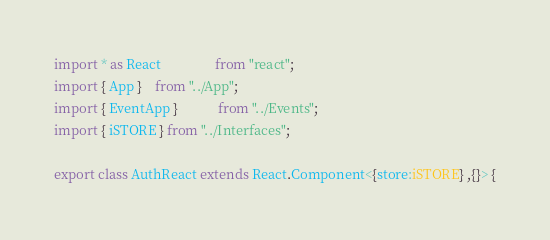<code> <loc_0><loc_0><loc_500><loc_500><_TypeScript_>import * as React 				from "react";
import { App } 	from "../App";
import { EventApp } 			from "../Events";
import { iSTORE } from "../Interfaces";

export class AuthReact extends React.Component<{store:iSTORE} ,{}> {
</code> 